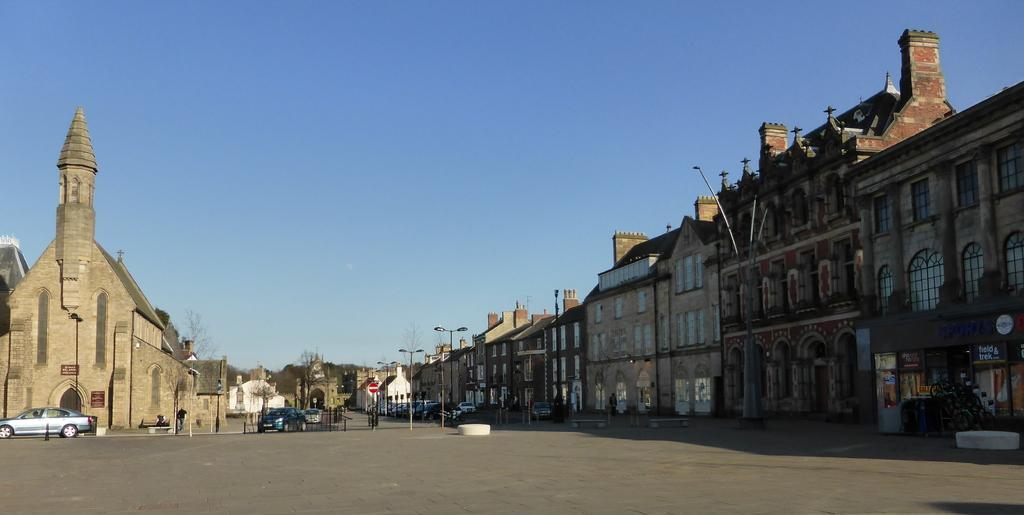What type of structures can be seen in the image? There are buildings in the image. What else can be seen in the image besides buildings? There are poles, trees, cars on the road, people, and the sky visible in the background. Can you describe the road in the image? The road is at the bottom of the image, and there are cars on it. What is the weather like in the image? The presence of the sky visible in the background suggests that the weather is clear. What type of riddle is being solved in the lunchroom in the image? There is no lunchroom or riddle present in the image. What example of a bird can be seen in the image? There is no bird present in the image. 